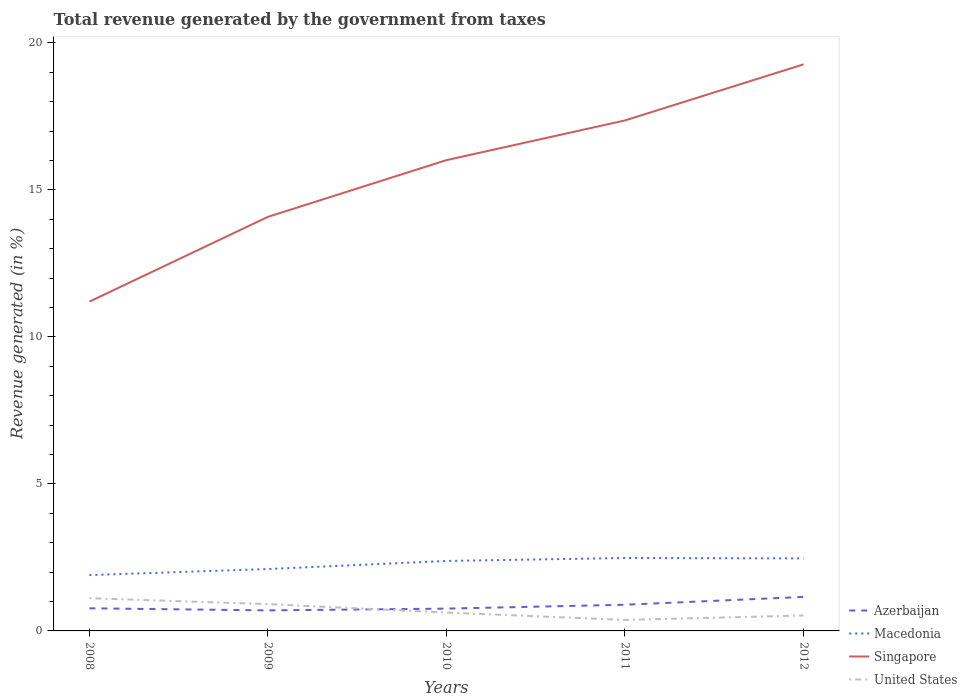How many different coloured lines are there?
Offer a very short reply. 4. Across all years, what is the maximum total revenue generated in Macedonia?
Make the answer very short. 1.9. In which year was the total revenue generated in Macedonia maximum?
Give a very brief answer. 2008. What is the total total revenue generated in Macedonia in the graph?
Make the answer very short. -0.09. What is the difference between the highest and the second highest total revenue generated in Azerbaijan?
Keep it short and to the point. 0.46. How many lines are there?
Your answer should be compact. 4. How many years are there in the graph?
Offer a very short reply. 5. What is the difference between two consecutive major ticks on the Y-axis?
Ensure brevity in your answer.  5. Does the graph contain any zero values?
Give a very brief answer. No. Does the graph contain grids?
Keep it short and to the point. No. Where does the legend appear in the graph?
Your answer should be compact. Bottom right. How many legend labels are there?
Provide a short and direct response. 4. How are the legend labels stacked?
Make the answer very short. Vertical. What is the title of the graph?
Your answer should be very brief. Total revenue generated by the government from taxes. Does "Latin America(all income levels)" appear as one of the legend labels in the graph?
Offer a terse response. No. What is the label or title of the X-axis?
Provide a succinct answer. Years. What is the label or title of the Y-axis?
Make the answer very short. Revenue generated (in %). What is the Revenue generated (in %) in Azerbaijan in 2008?
Keep it short and to the point. 0.77. What is the Revenue generated (in %) in Macedonia in 2008?
Make the answer very short. 1.9. What is the Revenue generated (in %) in Singapore in 2008?
Keep it short and to the point. 11.2. What is the Revenue generated (in %) in United States in 2008?
Offer a terse response. 1.11. What is the Revenue generated (in %) of Azerbaijan in 2009?
Your answer should be compact. 0.7. What is the Revenue generated (in %) in Macedonia in 2009?
Offer a very short reply. 2.1. What is the Revenue generated (in %) of Singapore in 2009?
Provide a short and direct response. 14.08. What is the Revenue generated (in %) in United States in 2009?
Provide a short and direct response. 0.91. What is the Revenue generated (in %) in Azerbaijan in 2010?
Make the answer very short. 0.76. What is the Revenue generated (in %) of Macedonia in 2010?
Your response must be concise. 2.38. What is the Revenue generated (in %) in Singapore in 2010?
Ensure brevity in your answer.  16.01. What is the Revenue generated (in %) of United States in 2010?
Keep it short and to the point. 0.62. What is the Revenue generated (in %) of Azerbaijan in 2011?
Give a very brief answer. 0.89. What is the Revenue generated (in %) in Macedonia in 2011?
Give a very brief answer. 2.48. What is the Revenue generated (in %) of Singapore in 2011?
Your answer should be compact. 17.36. What is the Revenue generated (in %) of United States in 2011?
Make the answer very short. 0.37. What is the Revenue generated (in %) of Azerbaijan in 2012?
Provide a succinct answer. 1.16. What is the Revenue generated (in %) in Macedonia in 2012?
Offer a very short reply. 2.47. What is the Revenue generated (in %) in Singapore in 2012?
Offer a terse response. 19.27. What is the Revenue generated (in %) of United States in 2012?
Ensure brevity in your answer.  0.52. Across all years, what is the maximum Revenue generated (in %) in Azerbaijan?
Provide a short and direct response. 1.16. Across all years, what is the maximum Revenue generated (in %) of Macedonia?
Keep it short and to the point. 2.48. Across all years, what is the maximum Revenue generated (in %) of Singapore?
Your answer should be compact. 19.27. Across all years, what is the maximum Revenue generated (in %) of United States?
Give a very brief answer. 1.11. Across all years, what is the minimum Revenue generated (in %) in Azerbaijan?
Your answer should be very brief. 0.7. Across all years, what is the minimum Revenue generated (in %) of Macedonia?
Give a very brief answer. 1.9. Across all years, what is the minimum Revenue generated (in %) of Singapore?
Provide a succinct answer. 11.2. Across all years, what is the minimum Revenue generated (in %) of United States?
Make the answer very short. 0.37. What is the total Revenue generated (in %) in Azerbaijan in the graph?
Make the answer very short. 4.27. What is the total Revenue generated (in %) in Macedonia in the graph?
Your response must be concise. 11.33. What is the total Revenue generated (in %) of Singapore in the graph?
Make the answer very short. 77.93. What is the total Revenue generated (in %) in United States in the graph?
Offer a very short reply. 3.55. What is the difference between the Revenue generated (in %) of Azerbaijan in 2008 and that in 2009?
Offer a very short reply. 0.07. What is the difference between the Revenue generated (in %) in Macedonia in 2008 and that in 2009?
Provide a short and direct response. -0.21. What is the difference between the Revenue generated (in %) in Singapore in 2008 and that in 2009?
Give a very brief answer. -2.88. What is the difference between the Revenue generated (in %) in United States in 2008 and that in 2009?
Your answer should be very brief. 0.2. What is the difference between the Revenue generated (in %) of Azerbaijan in 2008 and that in 2010?
Offer a very short reply. 0.01. What is the difference between the Revenue generated (in %) of Macedonia in 2008 and that in 2010?
Your answer should be compact. -0.48. What is the difference between the Revenue generated (in %) in Singapore in 2008 and that in 2010?
Offer a terse response. -4.81. What is the difference between the Revenue generated (in %) in United States in 2008 and that in 2010?
Ensure brevity in your answer.  0.49. What is the difference between the Revenue generated (in %) of Azerbaijan in 2008 and that in 2011?
Offer a very short reply. -0.12. What is the difference between the Revenue generated (in %) of Macedonia in 2008 and that in 2011?
Provide a succinct answer. -0.58. What is the difference between the Revenue generated (in %) in Singapore in 2008 and that in 2011?
Offer a terse response. -6.16. What is the difference between the Revenue generated (in %) in United States in 2008 and that in 2011?
Your response must be concise. 0.74. What is the difference between the Revenue generated (in %) of Azerbaijan in 2008 and that in 2012?
Your answer should be very brief. -0.39. What is the difference between the Revenue generated (in %) in Macedonia in 2008 and that in 2012?
Give a very brief answer. -0.57. What is the difference between the Revenue generated (in %) in Singapore in 2008 and that in 2012?
Offer a very short reply. -8.07. What is the difference between the Revenue generated (in %) of United States in 2008 and that in 2012?
Make the answer very short. 0.59. What is the difference between the Revenue generated (in %) in Azerbaijan in 2009 and that in 2010?
Provide a short and direct response. -0.06. What is the difference between the Revenue generated (in %) of Macedonia in 2009 and that in 2010?
Keep it short and to the point. -0.27. What is the difference between the Revenue generated (in %) of Singapore in 2009 and that in 2010?
Offer a terse response. -1.93. What is the difference between the Revenue generated (in %) in United States in 2009 and that in 2010?
Offer a very short reply. 0.29. What is the difference between the Revenue generated (in %) in Azerbaijan in 2009 and that in 2011?
Your answer should be very brief. -0.19. What is the difference between the Revenue generated (in %) in Macedonia in 2009 and that in 2011?
Your answer should be compact. -0.38. What is the difference between the Revenue generated (in %) in Singapore in 2009 and that in 2011?
Make the answer very short. -3.28. What is the difference between the Revenue generated (in %) in United States in 2009 and that in 2011?
Provide a short and direct response. 0.54. What is the difference between the Revenue generated (in %) of Azerbaijan in 2009 and that in 2012?
Keep it short and to the point. -0.46. What is the difference between the Revenue generated (in %) of Macedonia in 2009 and that in 2012?
Offer a terse response. -0.36. What is the difference between the Revenue generated (in %) in Singapore in 2009 and that in 2012?
Your response must be concise. -5.19. What is the difference between the Revenue generated (in %) of United States in 2009 and that in 2012?
Your answer should be very brief. 0.39. What is the difference between the Revenue generated (in %) in Azerbaijan in 2010 and that in 2011?
Keep it short and to the point. -0.13. What is the difference between the Revenue generated (in %) of Macedonia in 2010 and that in 2011?
Offer a very short reply. -0.1. What is the difference between the Revenue generated (in %) of Singapore in 2010 and that in 2011?
Provide a succinct answer. -1.35. What is the difference between the Revenue generated (in %) of United States in 2010 and that in 2011?
Ensure brevity in your answer.  0.25. What is the difference between the Revenue generated (in %) of Azerbaijan in 2010 and that in 2012?
Make the answer very short. -0.4. What is the difference between the Revenue generated (in %) of Macedonia in 2010 and that in 2012?
Your response must be concise. -0.09. What is the difference between the Revenue generated (in %) of Singapore in 2010 and that in 2012?
Provide a short and direct response. -3.26. What is the difference between the Revenue generated (in %) of United States in 2010 and that in 2012?
Your answer should be compact. 0.1. What is the difference between the Revenue generated (in %) in Azerbaijan in 2011 and that in 2012?
Provide a short and direct response. -0.27. What is the difference between the Revenue generated (in %) of Macedonia in 2011 and that in 2012?
Your response must be concise. 0.01. What is the difference between the Revenue generated (in %) in Singapore in 2011 and that in 2012?
Give a very brief answer. -1.91. What is the difference between the Revenue generated (in %) of United States in 2011 and that in 2012?
Offer a terse response. -0.15. What is the difference between the Revenue generated (in %) of Azerbaijan in 2008 and the Revenue generated (in %) of Macedonia in 2009?
Offer a very short reply. -1.34. What is the difference between the Revenue generated (in %) of Azerbaijan in 2008 and the Revenue generated (in %) of Singapore in 2009?
Offer a very short reply. -13.31. What is the difference between the Revenue generated (in %) of Azerbaijan in 2008 and the Revenue generated (in %) of United States in 2009?
Offer a terse response. -0.14. What is the difference between the Revenue generated (in %) in Macedonia in 2008 and the Revenue generated (in %) in Singapore in 2009?
Your answer should be compact. -12.19. What is the difference between the Revenue generated (in %) in Macedonia in 2008 and the Revenue generated (in %) in United States in 2009?
Offer a very short reply. 0.99. What is the difference between the Revenue generated (in %) of Singapore in 2008 and the Revenue generated (in %) of United States in 2009?
Your answer should be compact. 10.29. What is the difference between the Revenue generated (in %) of Azerbaijan in 2008 and the Revenue generated (in %) of Macedonia in 2010?
Provide a short and direct response. -1.61. What is the difference between the Revenue generated (in %) in Azerbaijan in 2008 and the Revenue generated (in %) in Singapore in 2010?
Your answer should be very brief. -15.24. What is the difference between the Revenue generated (in %) in Azerbaijan in 2008 and the Revenue generated (in %) in United States in 2010?
Provide a short and direct response. 0.14. What is the difference between the Revenue generated (in %) in Macedonia in 2008 and the Revenue generated (in %) in Singapore in 2010?
Ensure brevity in your answer.  -14.11. What is the difference between the Revenue generated (in %) in Macedonia in 2008 and the Revenue generated (in %) in United States in 2010?
Give a very brief answer. 1.27. What is the difference between the Revenue generated (in %) in Singapore in 2008 and the Revenue generated (in %) in United States in 2010?
Keep it short and to the point. 10.58. What is the difference between the Revenue generated (in %) in Azerbaijan in 2008 and the Revenue generated (in %) in Macedonia in 2011?
Your response must be concise. -1.71. What is the difference between the Revenue generated (in %) of Azerbaijan in 2008 and the Revenue generated (in %) of Singapore in 2011?
Offer a terse response. -16.59. What is the difference between the Revenue generated (in %) in Azerbaijan in 2008 and the Revenue generated (in %) in United States in 2011?
Give a very brief answer. 0.4. What is the difference between the Revenue generated (in %) of Macedonia in 2008 and the Revenue generated (in %) of Singapore in 2011?
Your answer should be very brief. -15.46. What is the difference between the Revenue generated (in %) in Macedonia in 2008 and the Revenue generated (in %) in United States in 2011?
Provide a succinct answer. 1.52. What is the difference between the Revenue generated (in %) in Singapore in 2008 and the Revenue generated (in %) in United States in 2011?
Ensure brevity in your answer.  10.83. What is the difference between the Revenue generated (in %) of Azerbaijan in 2008 and the Revenue generated (in %) of Macedonia in 2012?
Provide a succinct answer. -1.7. What is the difference between the Revenue generated (in %) of Azerbaijan in 2008 and the Revenue generated (in %) of Singapore in 2012?
Your response must be concise. -18.5. What is the difference between the Revenue generated (in %) in Azerbaijan in 2008 and the Revenue generated (in %) in United States in 2012?
Your answer should be very brief. 0.24. What is the difference between the Revenue generated (in %) of Macedonia in 2008 and the Revenue generated (in %) of Singapore in 2012?
Your response must be concise. -17.37. What is the difference between the Revenue generated (in %) in Macedonia in 2008 and the Revenue generated (in %) in United States in 2012?
Offer a terse response. 1.37. What is the difference between the Revenue generated (in %) in Singapore in 2008 and the Revenue generated (in %) in United States in 2012?
Give a very brief answer. 10.68. What is the difference between the Revenue generated (in %) in Azerbaijan in 2009 and the Revenue generated (in %) in Macedonia in 2010?
Your answer should be very brief. -1.68. What is the difference between the Revenue generated (in %) of Azerbaijan in 2009 and the Revenue generated (in %) of Singapore in 2010?
Keep it short and to the point. -15.31. What is the difference between the Revenue generated (in %) of Azerbaijan in 2009 and the Revenue generated (in %) of United States in 2010?
Give a very brief answer. 0.07. What is the difference between the Revenue generated (in %) of Macedonia in 2009 and the Revenue generated (in %) of Singapore in 2010?
Offer a very short reply. -13.91. What is the difference between the Revenue generated (in %) in Macedonia in 2009 and the Revenue generated (in %) in United States in 2010?
Give a very brief answer. 1.48. What is the difference between the Revenue generated (in %) in Singapore in 2009 and the Revenue generated (in %) in United States in 2010?
Your answer should be very brief. 13.46. What is the difference between the Revenue generated (in %) in Azerbaijan in 2009 and the Revenue generated (in %) in Macedonia in 2011?
Provide a succinct answer. -1.78. What is the difference between the Revenue generated (in %) of Azerbaijan in 2009 and the Revenue generated (in %) of Singapore in 2011?
Give a very brief answer. -16.66. What is the difference between the Revenue generated (in %) in Azerbaijan in 2009 and the Revenue generated (in %) in United States in 2011?
Provide a short and direct response. 0.32. What is the difference between the Revenue generated (in %) in Macedonia in 2009 and the Revenue generated (in %) in Singapore in 2011?
Make the answer very short. -15.26. What is the difference between the Revenue generated (in %) in Macedonia in 2009 and the Revenue generated (in %) in United States in 2011?
Provide a succinct answer. 1.73. What is the difference between the Revenue generated (in %) in Singapore in 2009 and the Revenue generated (in %) in United States in 2011?
Give a very brief answer. 13.71. What is the difference between the Revenue generated (in %) of Azerbaijan in 2009 and the Revenue generated (in %) of Macedonia in 2012?
Your response must be concise. -1.77. What is the difference between the Revenue generated (in %) of Azerbaijan in 2009 and the Revenue generated (in %) of Singapore in 2012?
Make the answer very short. -18.57. What is the difference between the Revenue generated (in %) of Azerbaijan in 2009 and the Revenue generated (in %) of United States in 2012?
Ensure brevity in your answer.  0.17. What is the difference between the Revenue generated (in %) of Macedonia in 2009 and the Revenue generated (in %) of Singapore in 2012?
Give a very brief answer. -17.17. What is the difference between the Revenue generated (in %) of Macedonia in 2009 and the Revenue generated (in %) of United States in 2012?
Provide a succinct answer. 1.58. What is the difference between the Revenue generated (in %) in Singapore in 2009 and the Revenue generated (in %) in United States in 2012?
Provide a short and direct response. 13.56. What is the difference between the Revenue generated (in %) in Azerbaijan in 2010 and the Revenue generated (in %) in Macedonia in 2011?
Provide a succinct answer. -1.72. What is the difference between the Revenue generated (in %) of Azerbaijan in 2010 and the Revenue generated (in %) of Singapore in 2011?
Ensure brevity in your answer.  -16.6. What is the difference between the Revenue generated (in %) in Azerbaijan in 2010 and the Revenue generated (in %) in United States in 2011?
Provide a succinct answer. 0.38. What is the difference between the Revenue generated (in %) of Macedonia in 2010 and the Revenue generated (in %) of Singapore in 2011?
Your answer should be very brief. -14.98. What is the difference between the Revenue generated (in %) of Macedonia in 2010 and the Revenue generated (in %) of United States in 2011?
Offer a very short reply. 2.01. What is the difference between the Revenue generated (in %) of Singapore in 2010 and the Revenue generated (in %) of United States in 2011?
Make the answer very short. 15.64. What is the difference between the Revenue generated (in %) of Azerbaijan in 2010 and the Revenue generated (in %) of Macedonia in 2012?
Offer a very short reply. -1.71. What is the difference between the Revenue generated (in %) of Azerbaijan in 2010 and the Revenue generated (in %) of Singapore in 2012?
Offer a very short reply. -18.51. What is the difference between the Revenue generated (in %) in Azerbaijan in 2010 and the Revenue generated (in %) in United States in 2012?
Your response must be concise. 0.23. What is the difference between the Revenue generated (in %) in Macedonia in 2010 and the Revenue generated (in %) in Singapore in 2012?
Keep it short and to the point. -16.89. What is the difference between the Revenue generated (in %) of Macedonia in 2010 and the Revenue generated (in %) of United States in 2012?
Keep it short and to the point. 1.85. What is the difference between the Revenue generated (in %) of Singapore in 2010 and the Revenue generated (in %) of United States in 2012?
Give a very brief answer. 15.49. What is the difference between the Revenue generated (in %) in Azerbaijan in 2011 and the Revenue generated (in %) in Macedonia in 2012?
Your answer should be compact. -1.58. What is the difference between the Revenue generated (in %) of Azerbaijan in 2011 and the Revenue generated (in %) of Singapore in 2012?
Keep it short and to the point. -18.38. What is the difference between the Revenue generated (in %) in Azerbaijan in 2011 and the Revenue generated (in %) in United States in 2012?
Ensure brevity in your answer.  0.37. What is the difference between the Revenue generated (in %) in Macedonia in 2011 and the Revenue generated (in %) in Singapore in 2012?
Offer a very short reply. -16.79. What is the difference between the Revenue generated (in %) of Macedonia in 2011 and the Revenue generated (in %) of United States in 2012?
Provide a short and direct response. 1.96. What is the difference between the Revenue generated (in %) of Singapore in 2011 and the Revenue generated (in %) of United States in 2012?
Offer a very short reply. 16.84. What is the average Revenue generated (in %) in Azerbaijan per year?
Make the answer very short. 0.85. What is the average Revenue generated (in %) in Macedonia per year?
Your answer should be very brief. 2.27. What is the average Revenue generated (in %) of Singapore per year?
Your answer should be compact. 15.59. What is the average Revenue generated (in %) in United States per year?
Your answer should be very brief. 0.71. In the year 2008, what is the difference between the Revenue generated (in %) of Azerbaijan and Revenue generated (in %) of Macedonia?
Offer a terse response. -1.13. In the year 2008, what is the difference between the Revenue generated (in %) of Azerbaijan and Revenue generated (in %) of Singapore?
Provide a succinct answer. -10.43. In the year 2008, what is the difference between the Revenue generated (in %) in Azerbaijan and Revenue generated (in %) in United States?
Provide a succinct answer. -0.34. In the year 2008, what is the difference between the Revenue generated (in %) in Macedonia and Revenue generated (in %) in Singapore?
Offer a terse response. -9.3. In the year 2008, what is the difference between the Revenue generated (in %) of Macedonia and Revenue generated (in %) of United States?
Give a very brief answer. 0.79. In the year 2008, what is the difference between the Revenue generated (in %) in Singapore and Revenue generated (in %) in United States?
Provide a succinct answer. 10.09. In the year 2009, what is the difference between the Revenue generated (in %) in Azerbaijan and Revenue generated (in %) in Macedonia?
Give a very brief answer. -1.41. In the year 2009, what is the difference between the Revenue generated (in %) in Azerbaijan and Revenue generated (in %) in Singapore?
Offer a terse response. -13.39. In the year 2009, what is the difference between the Revenue generated (in %) of Azerbaijan and Revenue generated (in %) of United States?
Your response must be concise. -0.21. In the year 2009, what is the difference between the Revenue generated (in %) of Macedonia and Revenue generated (in %) of Singapore?
Make the answer very short. -11.98. In the year 2009, what is the difference between the Revenue generated (in %) of Macedonia and Revenue generated (in %) of United States?
Keep it short and to the point. 1.19. In the year 2009, what is the difference between the Revenue generated (in %) of Singapore and Revenue generated (in %) of United States?
Your response must be concise. 13.17. In the year 2010, what is the difference between the Revenue generated (in %) in Azerbaijan and Revenue generated (in %) in Macedonia?
Make the answer very short. -1.62. In the year 2010, what is the difference between the Revenue generated (in %) in Azerbaijan and Revenue generated (in %) in Singapore?
Ensure brevity in your answer.  -15.25. In the year 2010, what is the difference between the Revenue generated (in %) in Azerbaijan and Revenue generated (in %) in United States?
Ensure brevity in your answer.  0.13. In the year 2010, what is the difference between the Revenue generated (in %) of Macedonia and Revenue generated (in %) of Singapore?
Provide a short and direct response. -13.63. In the year 2010, what is the difference between the Revenue generated (in %) in Macedonia and Revenue generated (in %) in United States?
Your answer should be very brief. 1.75. In the year 2010, what is the difference between the Revenue generated (in %) in Singapore and Revenue generated (in %) in United States?
Your answer should be very brief. 15.39. In the year 2011, what is the difference between the Revenue generated (in %) of Azerbaijan and Revenue generated (in %) of Macedonia?
Give a very brief answer. -1.59. In the year 2011, what is the difference between the Revenue generated (in %) of Azerbaijan and Revenue generated (in %) of Singapore?
Provide a succinct answer. -16.47. In the year 2011, what is the difference between the Revenue generated (in %) of Azerbaijan and Revenue generated (in %) of United States?
Provide a short and direct response. 0.52. In the year 2011, what is the difference between the Revenue generated (in %) of Macedonia and Revenue generated (in %) of Singapore?
Keep it short and to the point. -14.88. In the year 2011, what is the difference between the Revenue generated (in %) in Macedonia and Revenue generated (in %) in United States?
Your response must be concise. 2.11. In the year 2011, what is the difference between the Revenue generated (in %) in Singapore and Revenue generated (in %) in United States?
Offer a very short reply. 16.99. In the year 2012, what is the difference between the Revenue generated (in %) of Azerbaijan and Revenue generated (in %) of Macedonia?
Ensure brevity in your answer.  -1.31. In the year 2012, what is the difference between the Revenue generated (in %) in Azerbaijan and Revenue generated (in %) in Singapore?
Give a very brief answer. -18.11. In the year 2012, what is the difference between the Revenue generated (in %) of Azerbaijan and Revenue generated (in %) of United States?
Ensure brevity in your answer.  0.63. In the year 2012, what is the difference between the Revenue generated (in %) of Macedonia and Revenue generated (in %) of Singapore?
Your answer should be very brief. -16.8. In the year 2012, what is the difference between the Revenue generated (in %) of Macedonia and Revenue generated (in %) of United States?
Ensure brevity in your answer.  1.94. In the year 2012, what is the difference between the Revenue generated (in %) in Singapore and Revenue generated (in %) in United States?
Provide a short and direct response. 18.75. What is the ratio of the Revenue generated (in %) of Azerbaijan in 2008 to that in 2009?
Your response must be concise. 1.1. What is the ratio of the Revenue generated (in %) in Macedonia in 2008 to that in 2009?
Ensure brevity in your answer.  0.9. What is the ratio of the Revenue generated (in %) of Singapore in 2008 to that in 2009?
Keep it short and to the point. 0.8. What is the ratio of the Revenue generated (in %) in United States in 2008 to that in 2009?
Offer a very short reply. 1.22. What is the ratio of the Revenue generated (in %) of Azerbaijan in 2008 to that in 2010?
Give a very brief answer. 1.01. What is the ratio of the Revenue generated (in %) of Macedonia in 2008 to that in 2010?
Keep it short and to the point. 0.8. What is the ratio of the Revenue generated (in %) in Singapore in 2008 to that in 2010?
Make the answer very short. 0.7. What is the ratio of the Revenue generated (in %) of United States in 2008 to that in 2010?
Give a very brief answer. 1.78. What is the ratio of the Revenue generated (in %) of Azerbaijan in 2008 to that in 2011?
Offer a very short reply. 0.86. What is the ratio of the Revenue generated (in %) in Macedonia in 2008 to that in 2011?
Give a very brief answer. 0.77. What is the ratio of the Revenue generated (in %) of Singapore in 2008 to that in 2011?
Make the answer very short. 0.65. What is the ratio of the Revenue generated (in %) of United States in 2008 to that in 2011?
Your answer should be very brief. 2.97. What is the ratio of the Revenue generated (in %) in Azerbaijan in 2008 to that in 2012?
Your response must be concise. 0.67. What is the ratio of the Revenue generated (in %) in Macedonia in 2008 to that in 2012?
Provide a short and direct response. 0.77. What is the ratio of the Revenue generated (in %) of Singapore in 2008 to that in 2012?
Keep it short and to the point. 0.58. What is the ratio of the Revenue generated (in %) of United States in 2008 to that in 2012?
Ensure brevity in your answer.  2.12. What is the ratio of the Revenue generated (in %) in Azerbaijan in 2009 to that in 2010?
Keep it short and to the point. 0.92. What is the ratio of the Revenue generated (in %) in Macedonia in 2009 to that in 2010?
Ensure brevity in your answer.  0.88. What is the ratio of the Revenue generated (in %) of Singapore in 2009 to that in 2010?
Keep it short and to the point. 0.88. What is the ratio of the Revenue generated (in %) of United States in 2009 to that in 2010?
Offer a terse response. 1.46. What is the ratio of the Revenue generated (in %) in Azerbaijan in 2009 to that in 2011?
Ensure brevity in your answer.  0.78. What is the ratio of the Revenue generated (in %) in Macedonia in 2009 to that in 2011?
Give a very brief answer. 0.85. What is the ratio of the Revenue generated (in %) of Singapore in 2009 to that in 2011?
Your answer should be very brief. 0.81. What is the ratio of the Revenue generated (in %) of United States in 2009 to that in 2011?
Your response must be concise. 2.44. What is the ratio of the Revenue generated (in %) of Azerbaijan in 2009 to that in 2012?
Ensure brevity in your answer.  0.6. What is the ratio of the Revenue generated (in %) in Macedonia in 2009 to that in 2012?
Provide a succinct answer. 0.85. What is the ratio of the Revenue generated (in %) of Singapore in 2009 to that in 2012?
Offer a very short reply. 0.73. What is the ratio of the Revenue generated (in %) in United States in 2009 to that in 2012?
Ensure brevity in your answer.  1.74. What is the ratio of the Revenue generated (in %) of Azerbaijan in 2010 to that in 2011?
Ensure brevity in your answer.  0.85. What is the ratio of the Revenue generated (in %) of Macedonia in 2010 to that in 2011?
Ensure brevity in your answer.  0.96. What is the ratio of the Revenue generated (in %) in Singapore in 2010 to that in 2011?
Offer a very short reply. 0.92. What is the ratio of the Revenue generated (in %) in United States in 2010 to that in 2011?
Ensure brevity in your answer.  1.67. What is the ratio of the Revenue generated (in %) of Azerbaijan in 2010 to that in 2012?
Ensure brevity in your answer.  0.66. What is the ratio of the Revenue generated (in %) of Macedonia in 2010 to that in 2012?
Provide a succinct answer. 0.96. What is the ratio of the Revenue generated (in %) of Singapore in 2010 to that in 2012?
Keep it short and to the point. 0.83. What is the ratio of the Revenue generated (in %) in United States in 2010 to that in 2012?
Make the answer very short. 1.19. What is the ratio of the Revenue generated (in %) of Azerbaijan in 2011 to that in 2012?
Your answer should be very brief. 0.77. What is the ratio of the Revenue generated (in %) of Macedonia in 2011 to that in 2012?
Offer a very short reply. 1.01. What is the ratio of the Revenue generated (in %) of Singapore in 2011 to that in 2012?
Offer a terse response. 0.9. What is the ratio of the Revenue generated (in %) in United States in 2011 to that in 2012?
Your answer should be compact. 0.71. What is the difference between the highest and the second highest Revenue generated (in %) of Azerbaijan?
Your answer should be compact. 0.27. What is the difference between the highest and the second highest Revenue generated (in %) in Macedonia?
Keep it short and to the point. 0.01. What is the difference between the highest and the second highest Revenue generated (in %) in Singapore?
Your answer should be very brief. 1.91. What is the difference between the highest and the second highest Revenue generated (in %) in United States?
Your answer should be compact. 0.2. What is the difference between the highest and the lowest Revenue generated (in %) of Azerbaijan?
Offer a very short reply. 0.46. What is the difference between the highest and the lowest Revenue generated (in %) in Macedonia?
Provide a short and direct response. 0.58. What is the difference between the highest and the lowest Revenue generated (in %) of Singapore?
Give a very brief answer. 8.07. What is the difference between the highest and the lowest Revenue generated (in %) in United States?
Provide a short and direct response. 0.74. 